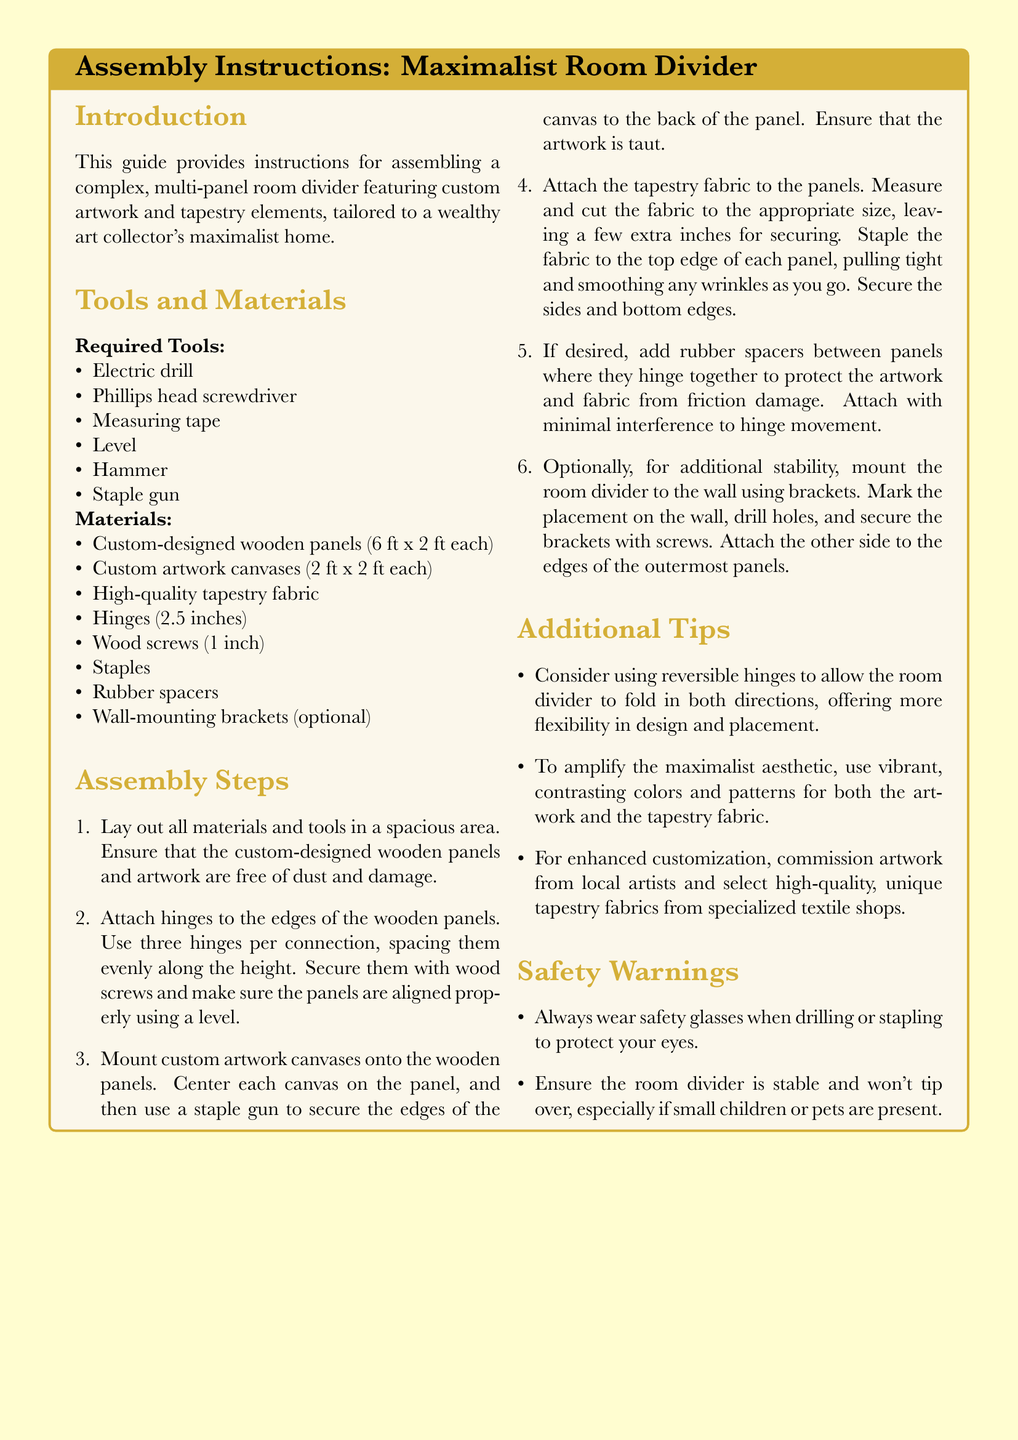what is the size of the custom-designed wooden panels? The dimensions of the wooden panels are stated in the document as 6 ft x 2 ft each.
Answer: 6 ft x 2 ft how many hinges are required per connection? The document specifies that three hinges should be used for each connection.
Answer: three what is one tool needed for assembly? The list of required tools includes several items; one example is an electric drill.
Answer: electric drill how should the custom artwork canvases be secured to the panels? The instruction indicates that staple guns should be used to secure the canvases to the panels.
Answer: staple gun what optional feature can enhance the room divider's flexibility? The document recommends considering the use of reversible hinges for added flexibility.
Answer: reversible hinges how should the tapestry fabric be attached to the panels? The steps indicate that tapestry fabric should be stapled to the top edge of each panel.
Answer: stapled what type of brackets can be used for additional stability? The document mentions wall-mounting brackets as an optional stabilization method.
Answer: wall-mounting brackets what is a safety warning mentioned in the document? The document warns to always wear safety glasses when drilling or stapling.
Answer: wear safety glasses how many panels are suggested for the room divider? The document mentions that the assembly involves several wooden panels; each assembly step refers to connecting multiple panels but does not specify a number.
Answer: not specified 